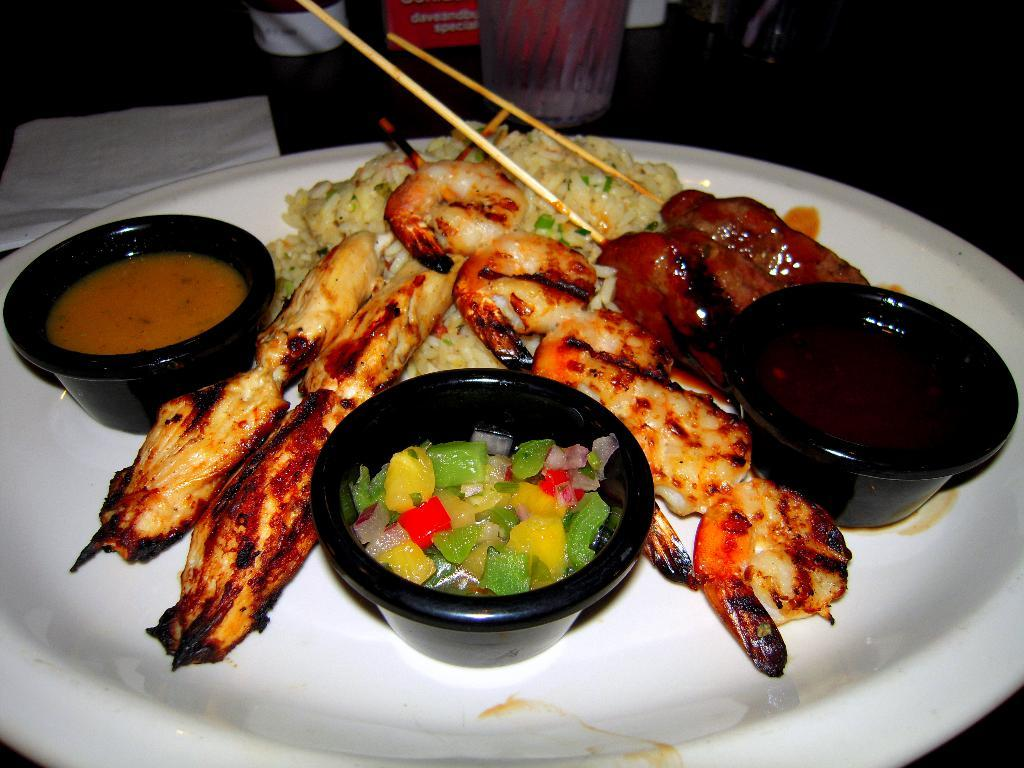What types of objects can be seen in the image? There are objects such as a glass, tissue paper, chopsticks, and black bowls in the image. Can you describe the glass in the image? There is a glass in the image. What is present alongside the tissue paper in the image? There are chopsticks in the image. What is being served on the plate in the image? There is food in a plate in the image. What color are the bowls in the image? The bowls in the image are black. Can you tell me how many islands are visible in the image? There are no islands present in the image. What type of appliance is being offered by the person in the image? There is no person or appliance present in the image. 